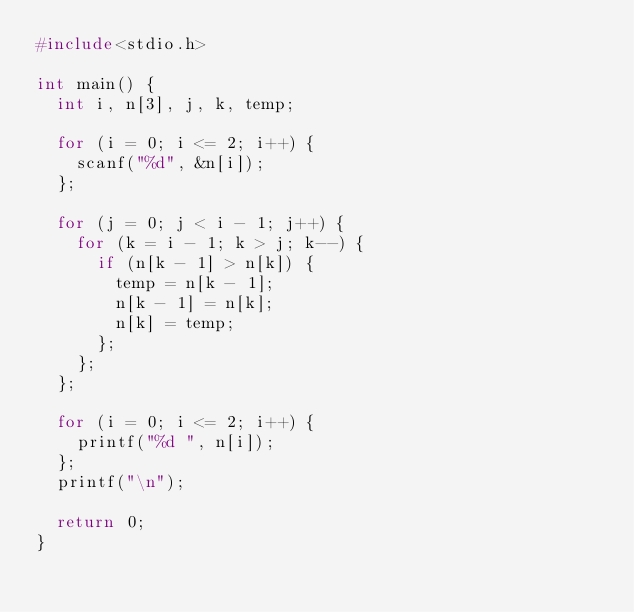Convert code to text. <code><loc_0><loc_0><loc_500><loc_500><_C_>#include<stdio.h>
  
int main() {
  int i, n[3], j, k, temp;
  
  for (i = 0; i <= 2; i++) {
    scanf("%d", &n[i]);
  };
    
  for (j = 0; j < i - 1; j++) {
    for (k = i - 1; k > j; k--) {
      if (n[k - 1] > n[k]) {
        temp = n[k - 1];
        n[k - 1] = n[k];
        n[k] = temp;
      };
    };
  };
  
  for (i = 0; i <= 2; i++) {
    printf("%d ", n[i]);
  };
  printf("\n");
  
  return 0;
}</code> 